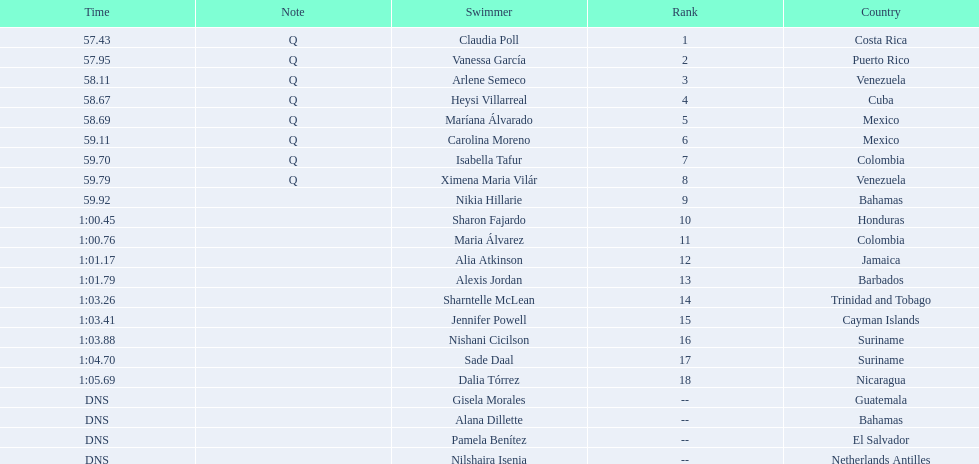Who was the only cuban to finish in the top eight? Heysi Villarreal. 